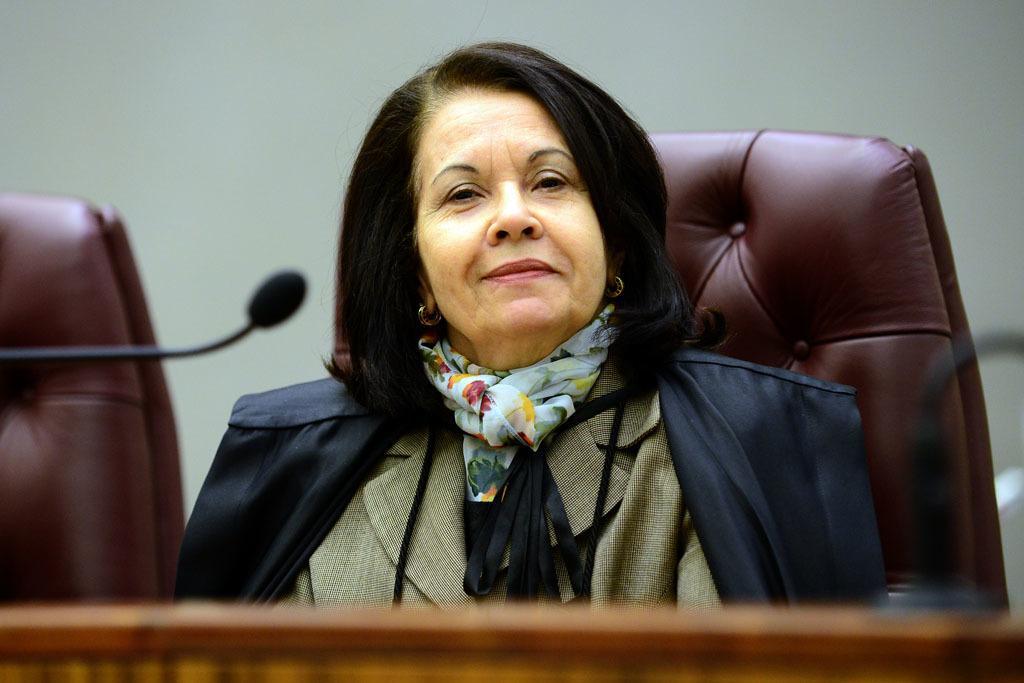How would you summarize this image in a sentence or two? A woman is sitting on the chair, she wore coat and also she is smiling. 